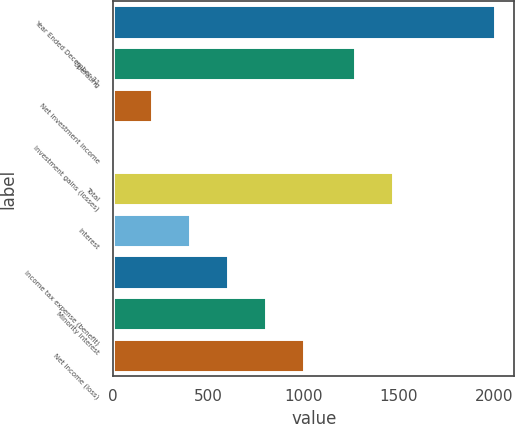Convert chart. <chart><loc_0><loc_0><loc_500><loc_500><bar_chart><fcel>Year Ended December 31<fcel>Operating<fcel>Net investment income<fcel>Investment gains (losses)<fcel>Total<fcel>Interest<fcel>Income tax expense (benefit)<fcel>Minority interest<fcel>Net income (loss)<nl><fcel>2005<fcel>1268.1<fcel>201.58<fcel>1.2<fcel>1468.48<fcel>401.96<fcel>602.34<fcel>802.72<fcel>1003.1<nl></chart> 